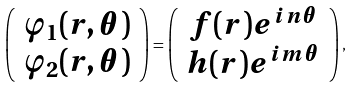Convert formula to latex. <formula><loc_0><loc_0><loc_500><loc_500>\left ( \begin{array} { c } \varphi _ { 1 } ( r , \theta ) \\ \varphi _ { 2 } ( r , \theta ) \end{array} \right ) = \left ( \begin{array} { c } f ( r ) e ^ { i n \theta } \\ h ( r ) e ^ { i m \theta } \end{array} \right ) ,</formula> 